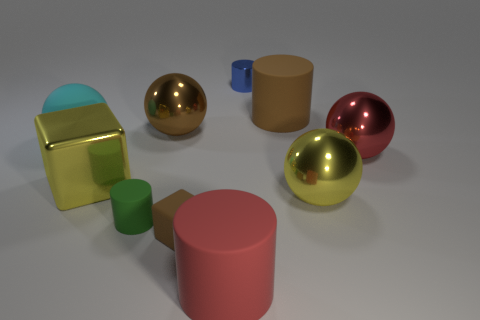The cyan thing that is the same size as the yellow sphere is what shape?
Offer a very short reply. Sphere. Is there a green object of the same shape as the big red metal object?
Your answer should be very brief. No. There is a large cylinder in front of the small matte thing that is behind the brown matte block; is there a large yellow metal object in front of it?
Keep it short and to the point. No. Are there more small green matte things behind the large cyan rubber sphere than big red shiny objects that are in front of the brown block?
Ensure brevity in your answer.  No. What material is the cube that is the same size as the brown ball?
Your response must be concise. Metal. How many small objects are yellow metal balls or metallic things?
Provide a short and direct response. 1. Is the shape of the tiny metal object the same as the small brown rubber thing?
Offer a very short reply. No. How many large things are to the right of the rubber sphere and on the left side of the tiny matte cylinder?
Keep it short and to the point. 1. Is there anything else of the same color as the small cube?
Your answer should be compact. Yes. There is a blue thing that is made of the same material as the large brown sphere; what is its shape?
Offer a terse response. Cylinder. 